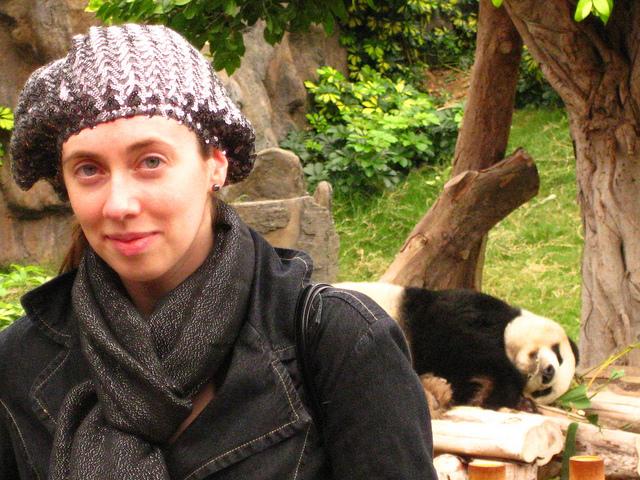Is this scene indoors?
Write a very short answer. No. Is the girl wearing a scarf?
Answer briefly. Yes. What type of animal is in the back?
Give a very brief answer. Panda. 